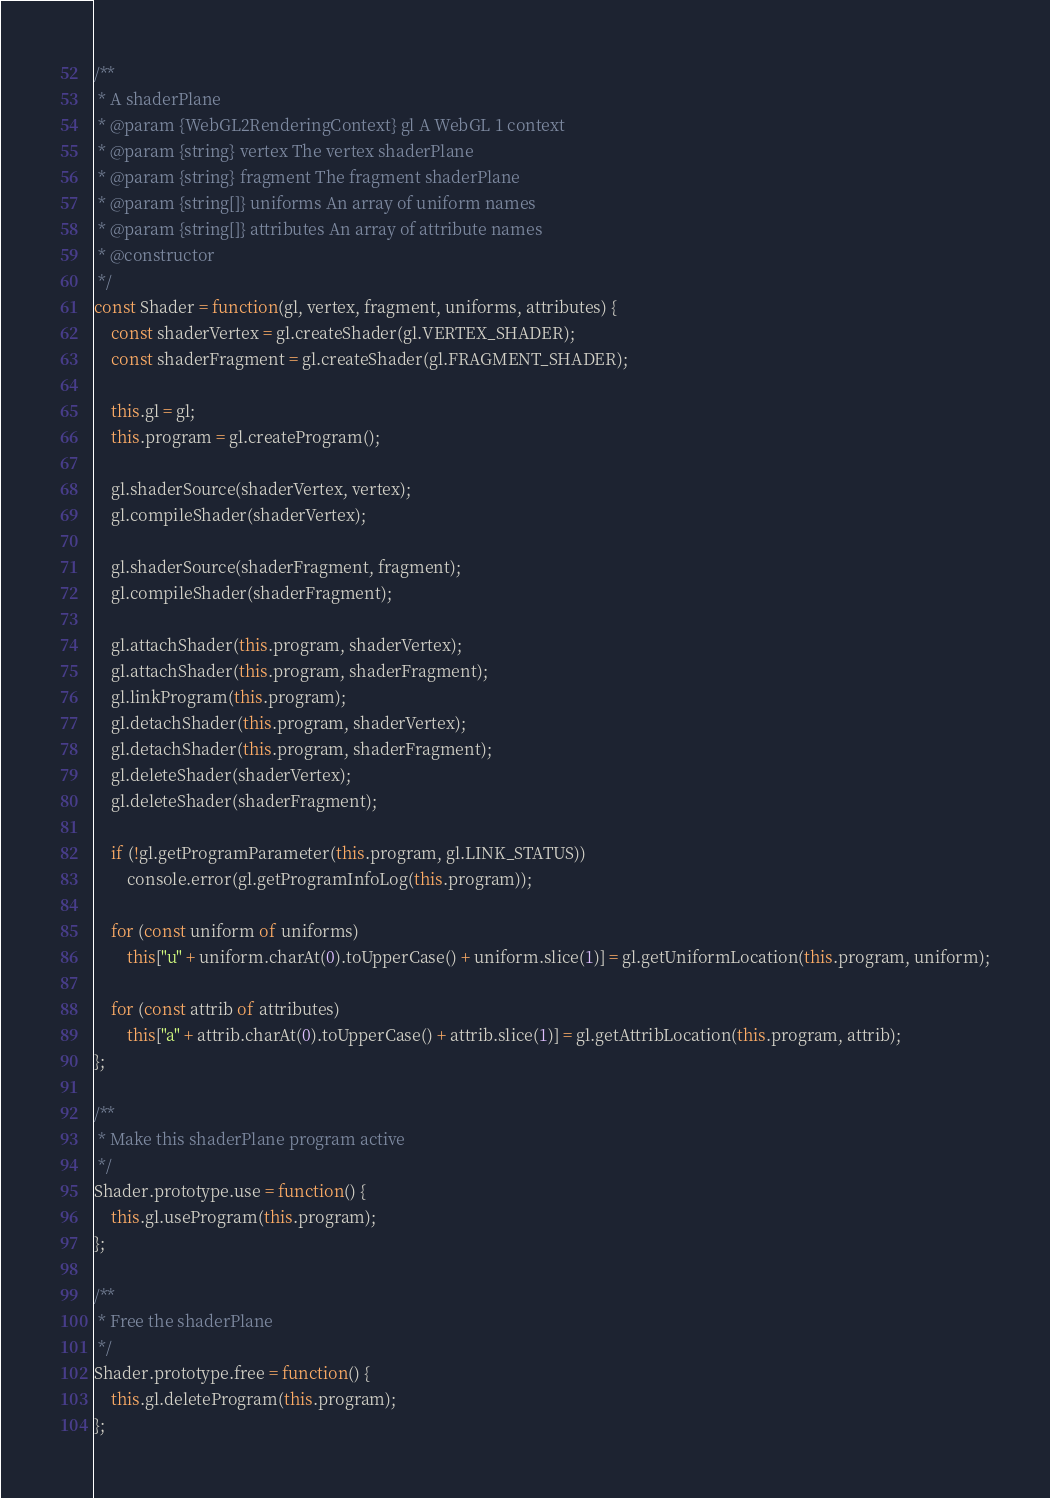<code> <loc_0><loc_0><loc_500><loc_500><_JavaScript_>/**
 * A shaderPlane
 * @param {WebGL2RenderingContext} gl A WebGL 1 context
 * @param {string} vertex The vertex shaderPlane
 * @param {string} fragment The fragment shaderPlane
 * @param {string[]} uniforms An array of uniform names
 * @param {string[]} attributes An array of attribute names
 * @constructor
 */
const Shader = function(gl, vertex, fragment, uniforms, attributes) {
    const shaderVertex = gl.createShader(gl.VERTEX_SHADER);
    const shaderFragment = gl.createShader(gl.FRAGMENT_SHADER);

    this.gl = gl;
    this.program = gl.createProgram();

    gl.shaderSource(shaderVertex, vertex);
    gl.compileShader(shaderVertex);

    gl.shaderSource(shaderFragment, fragment);
    gl.compileShader(shaderFragment);

    gl.attachShader(this.program, shaderVertex);
    gl.attachShader(this.program, shaderFragment);
    gl.linkProgram(this.program);
    gl.detachShader(this.program, shaderVertex);
    gl.detachShader(this.program, shaderFragment);
    gl.deleteShader(shaderVertex);
    gl.deleteShader(shaderFragment);

    if (!gl.getProgramParameter(this.program, gl.LINK_STATUS))
        console.error(gl.getProgramInfoLog(this.program));

    for (const uniform of uniforms)
        this["u" + uniform.charAt(0).toUpperCase() + uniform.slice(1)] = gl.getUniformLocation(this.program, uniform);

    for (const attrib of attributes)
        this["a" + attrib.charAt(0).toUpperCase() + attrib.slice(1)] = gl.getAttribLocation(this.program, attrib);
};

/**
 * Make this shaderPlane program active
 */
Shader.prototype.use = function() {
    this.gl.useProgram(this.program);
};

/**
 * Free the shaderPlane
 */
Shader.prototype.free = function() {
    this.gl.deleteProgram(this.program);
};</code> 